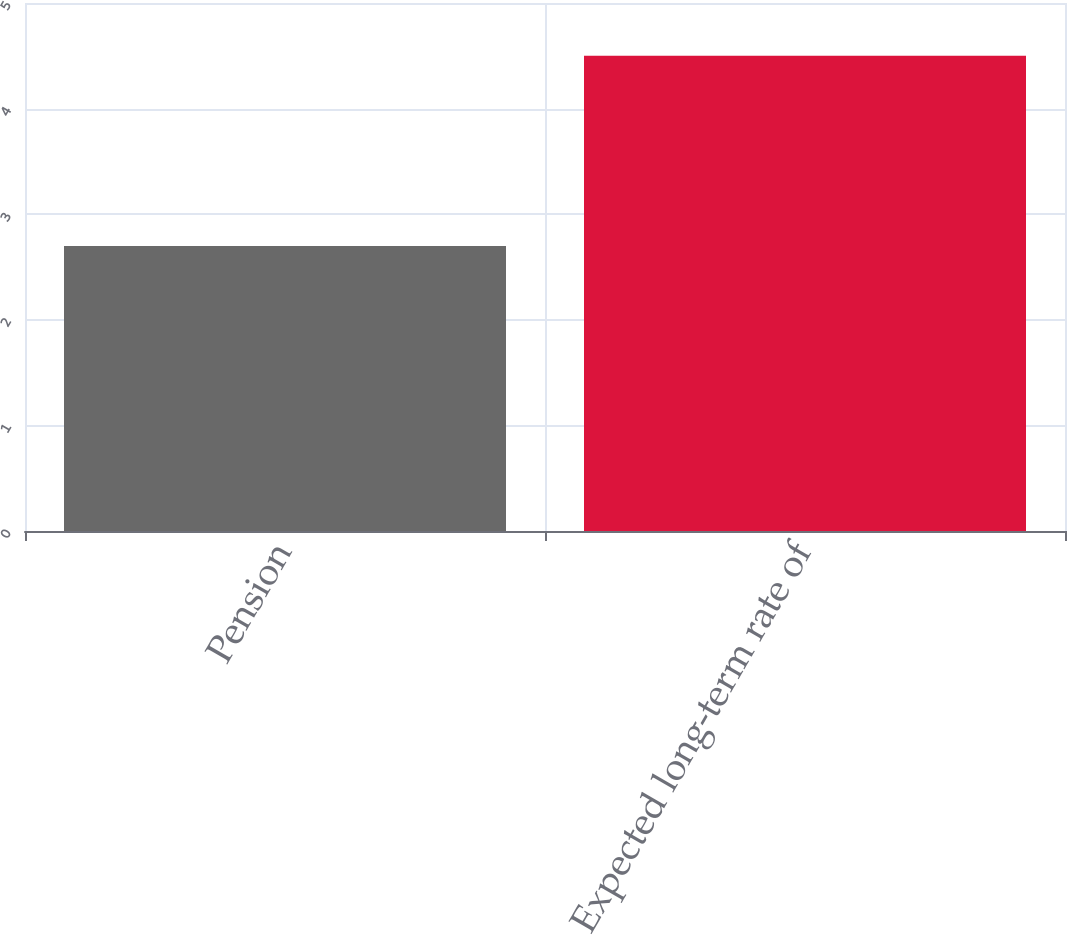<chart> <loc_0><loc_0><loc_500><loc_500><bar_chart><fcel>Pension<fcel>Expected long-term rate of<nl><fcel>2.7<fcel>4.5<nl></chart> 